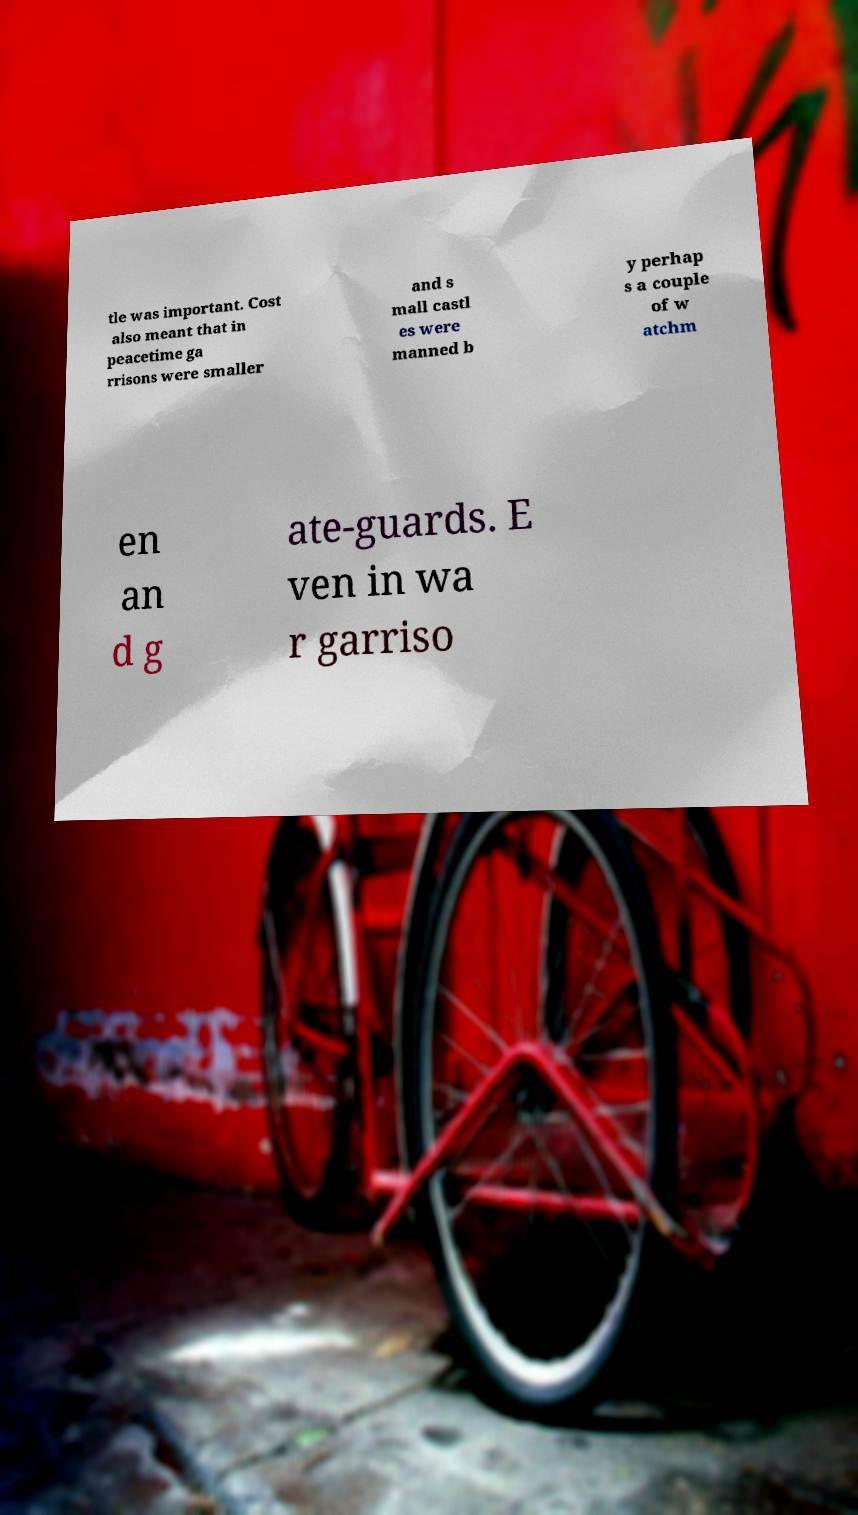Please read and relay the text visible in this image. What does it say? tle was important. Cost also meant that in peacetime ga rrisons were smaller and s mall castl es were manned b y perhap s a couple of w atchm en an d g ate-guards. E ven in wa r garriso 